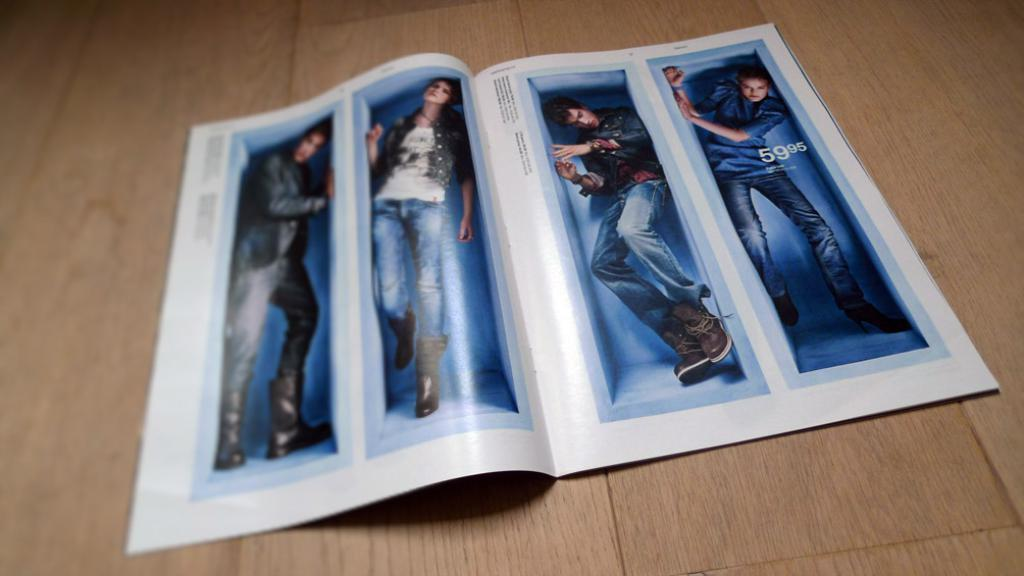What is the main object in the image? There is a poster in the image. What is depicted on the poster? The poster contains a collage of four images. Are there any words on the poster? Yes, there is text on the poster. How many people are shown in the images on the poster? There are four persons in the images. What type of music can be heard playing in the background of the poster? There is no music present in the image, as it is a static poster with images and text. 